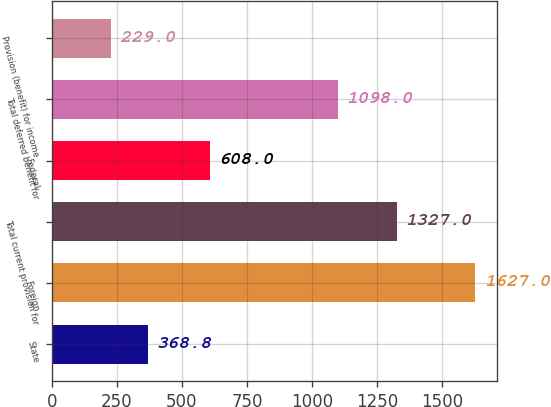<chart> <loc_0><loc_0><loc_500><loc_500><bar_chart><fcel>State<fcel>Foreign<fcel>Total current provision for<fcel>Federal<fcel>Total deferred benefit for<fcel>Provision (benefit) for income<nl><fcel>368.8<fcel>1627<fcel>1327<fcel>608<fcel>1098<fcel>229<nl></chart> 